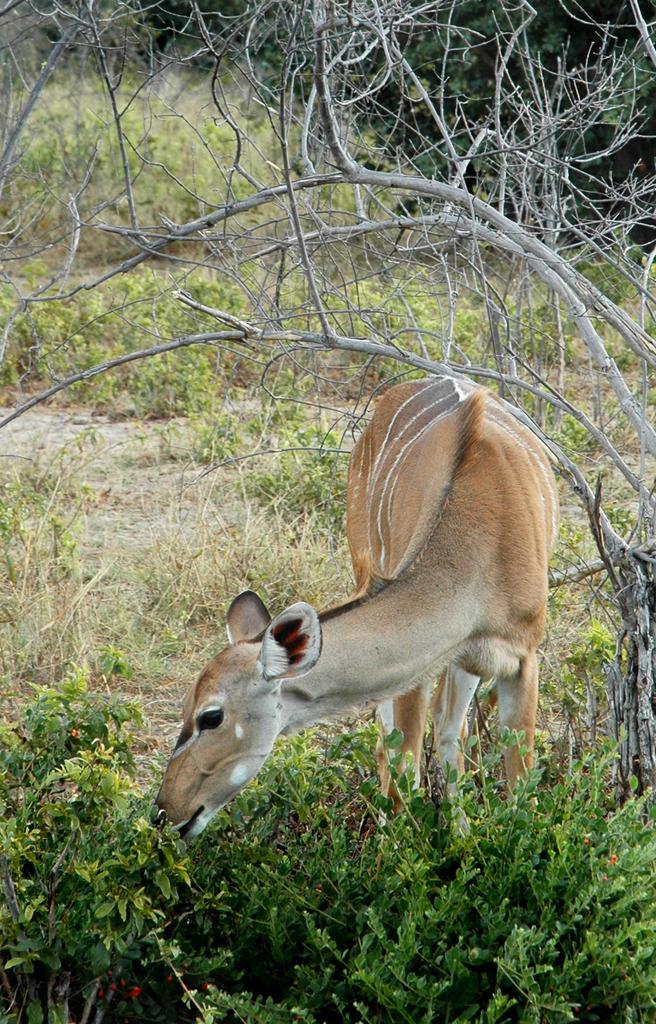In one or two sentences, can you explain what this image depicts? Here I can see an animal is eating leaves of a plant. Here I can see many plants on the ground. At the top of the image there are stems of a tree. 